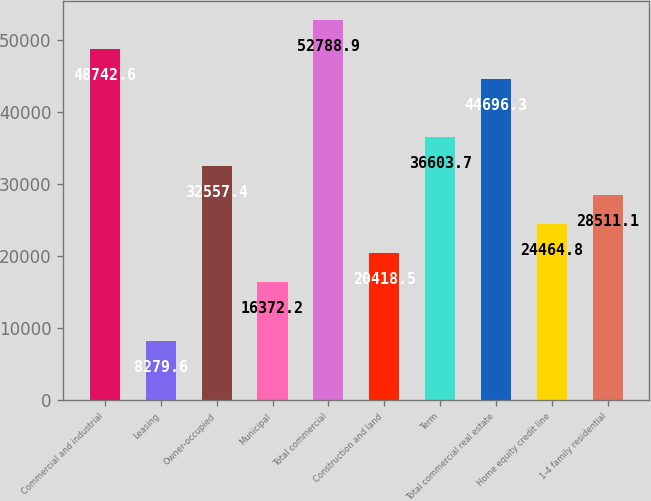Convert chart. <chart><loc_0><loc_0><loc_500><loc_500><bar_chart><fcel>Commercial and industrial<fcel>Leasing<fcel>Owner-occupied<fcel>Municipal<fcel>Total commercial<fcel>Construction and land<fcel>Term<fcel>Total commercial real estate<fcel>Home equity credit line<fcel>1-4 family residential<nl><fcel>48742.6<fcel>8279.6<fcel>32557.4<fcel>16372.2<fcel>52788.9<fcel>20418.5<fcel>36603.7<fcel>44696.3<fcel>24464.8<fcel>28511.1<nl></chart> 